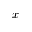<formula> <loc_0><loc_0><loc_500><loc_500>x</formula> 